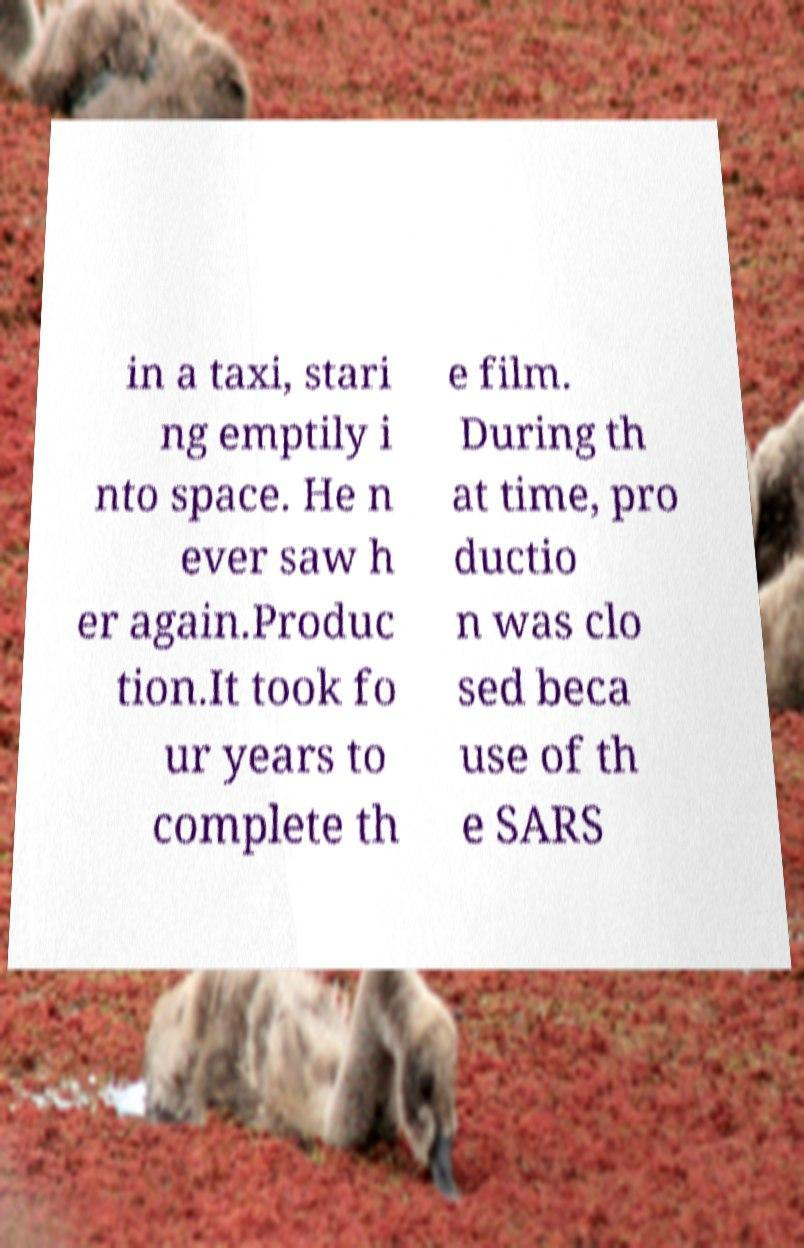Please read and relay the text visible in this image. What does it say? in a taxi, stari ng emptily i nto space. He n ever saw h er again.Produc tion.It took fo ur years to complete th e film. During th at time, pro ductio n was clo sed beca use of th e SARS 